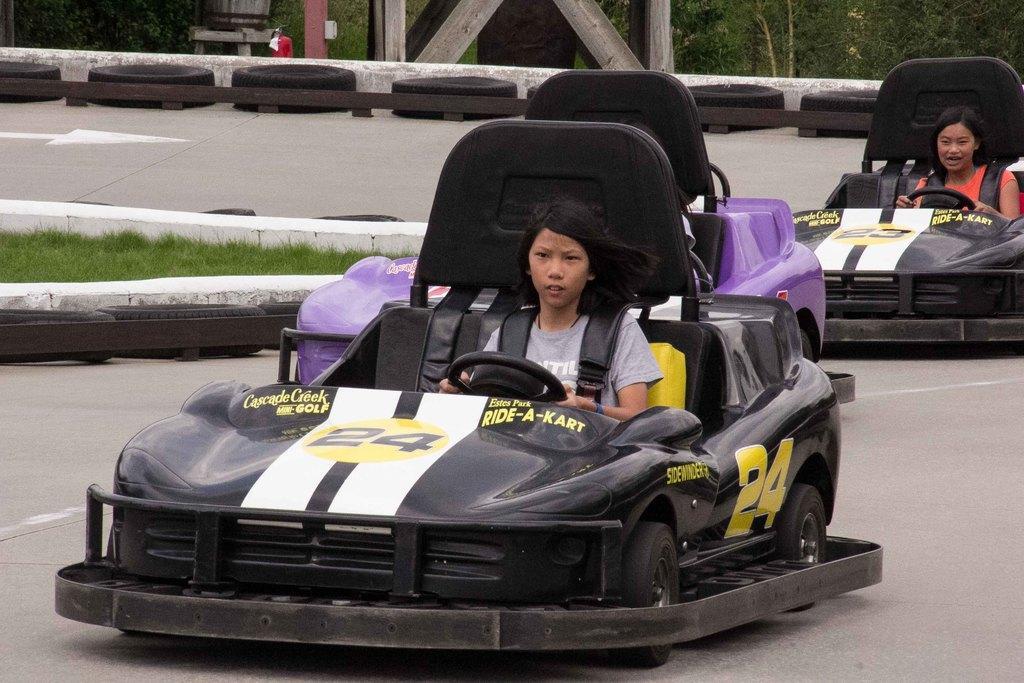Could you give a brief overview of what you see in this image? In this image two girls are driving a car. There are many trees at the top most of the image, few tires are placed aside on the road. 